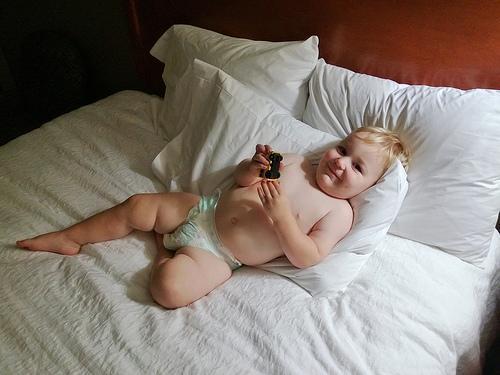How many people are in the picture?
Give a very brief answer. 1. How many pillows are on the bed?
Give a very brief answer. 3. 